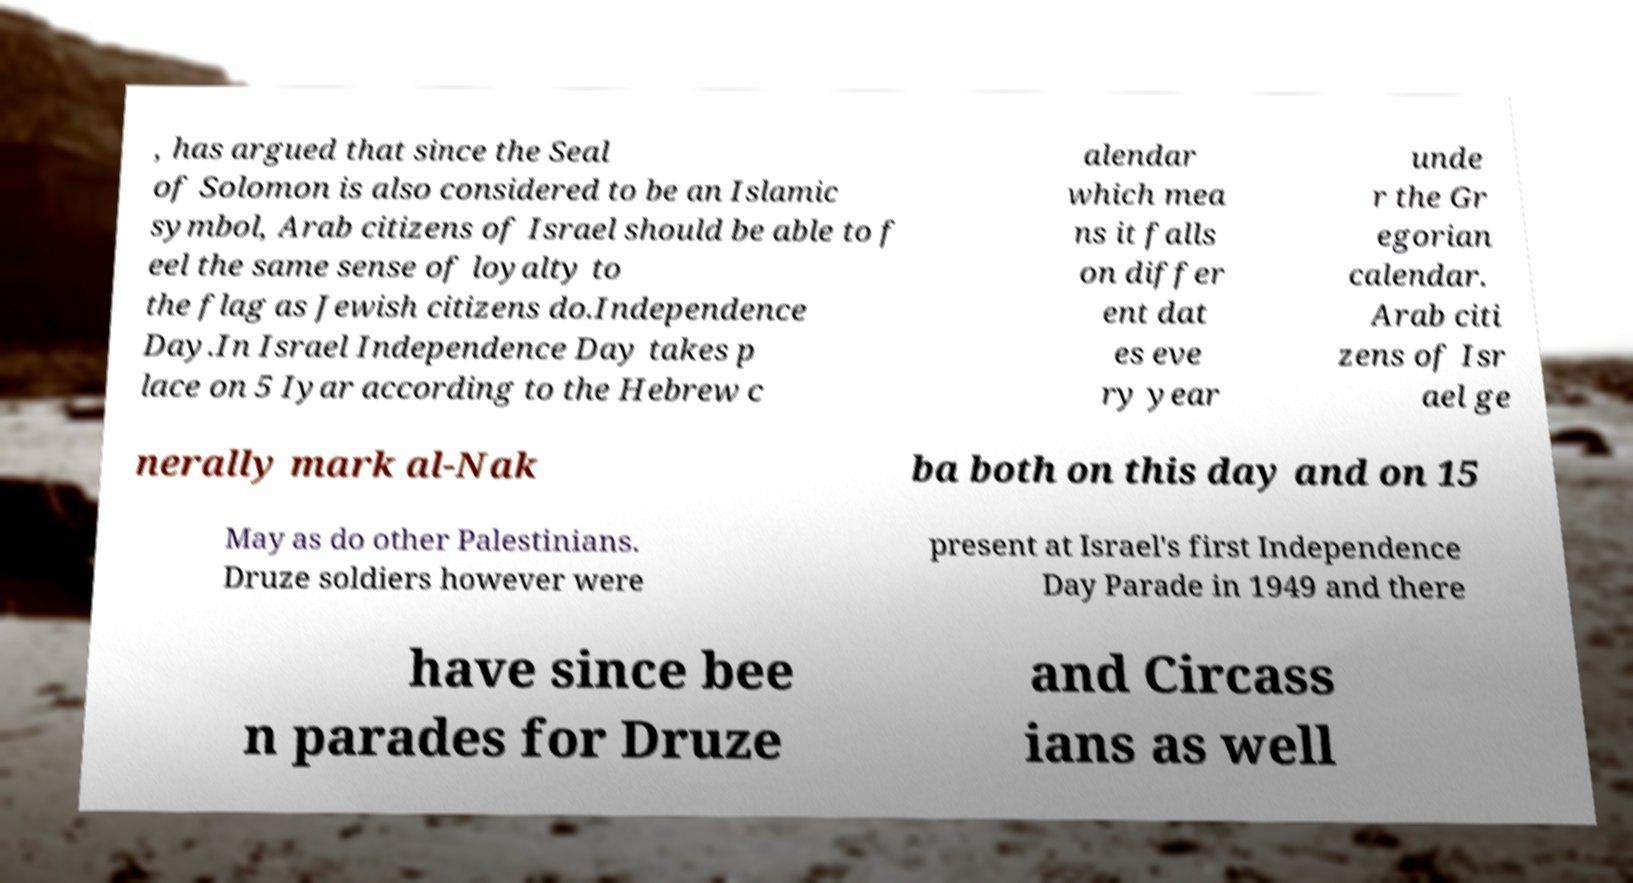Please read and relay the text visible in this image. What does it say? , has argued that since the Seal of Solomon is also considered to be an Islamic symbol, Arab citizens of Israel should be able to f eel the same sense of loyalty to the flag as Jewish citizens do.Independence Day.In Israel Independence Day takes p lace on 5 Iyar according to the Hebrew c alendar which mea ns it falls on differ ent dat es eve ry year unde r the Gr egorian calendar. Arab citi zens of Isr ael ge nerally mark al-Nak ba both on this day and on 15 May as do other Palestinians. Druze soldiers however were present at Israel's first Independence Day Parade in 1949 and there have since bee n parades for Druze and Circass ians as well 